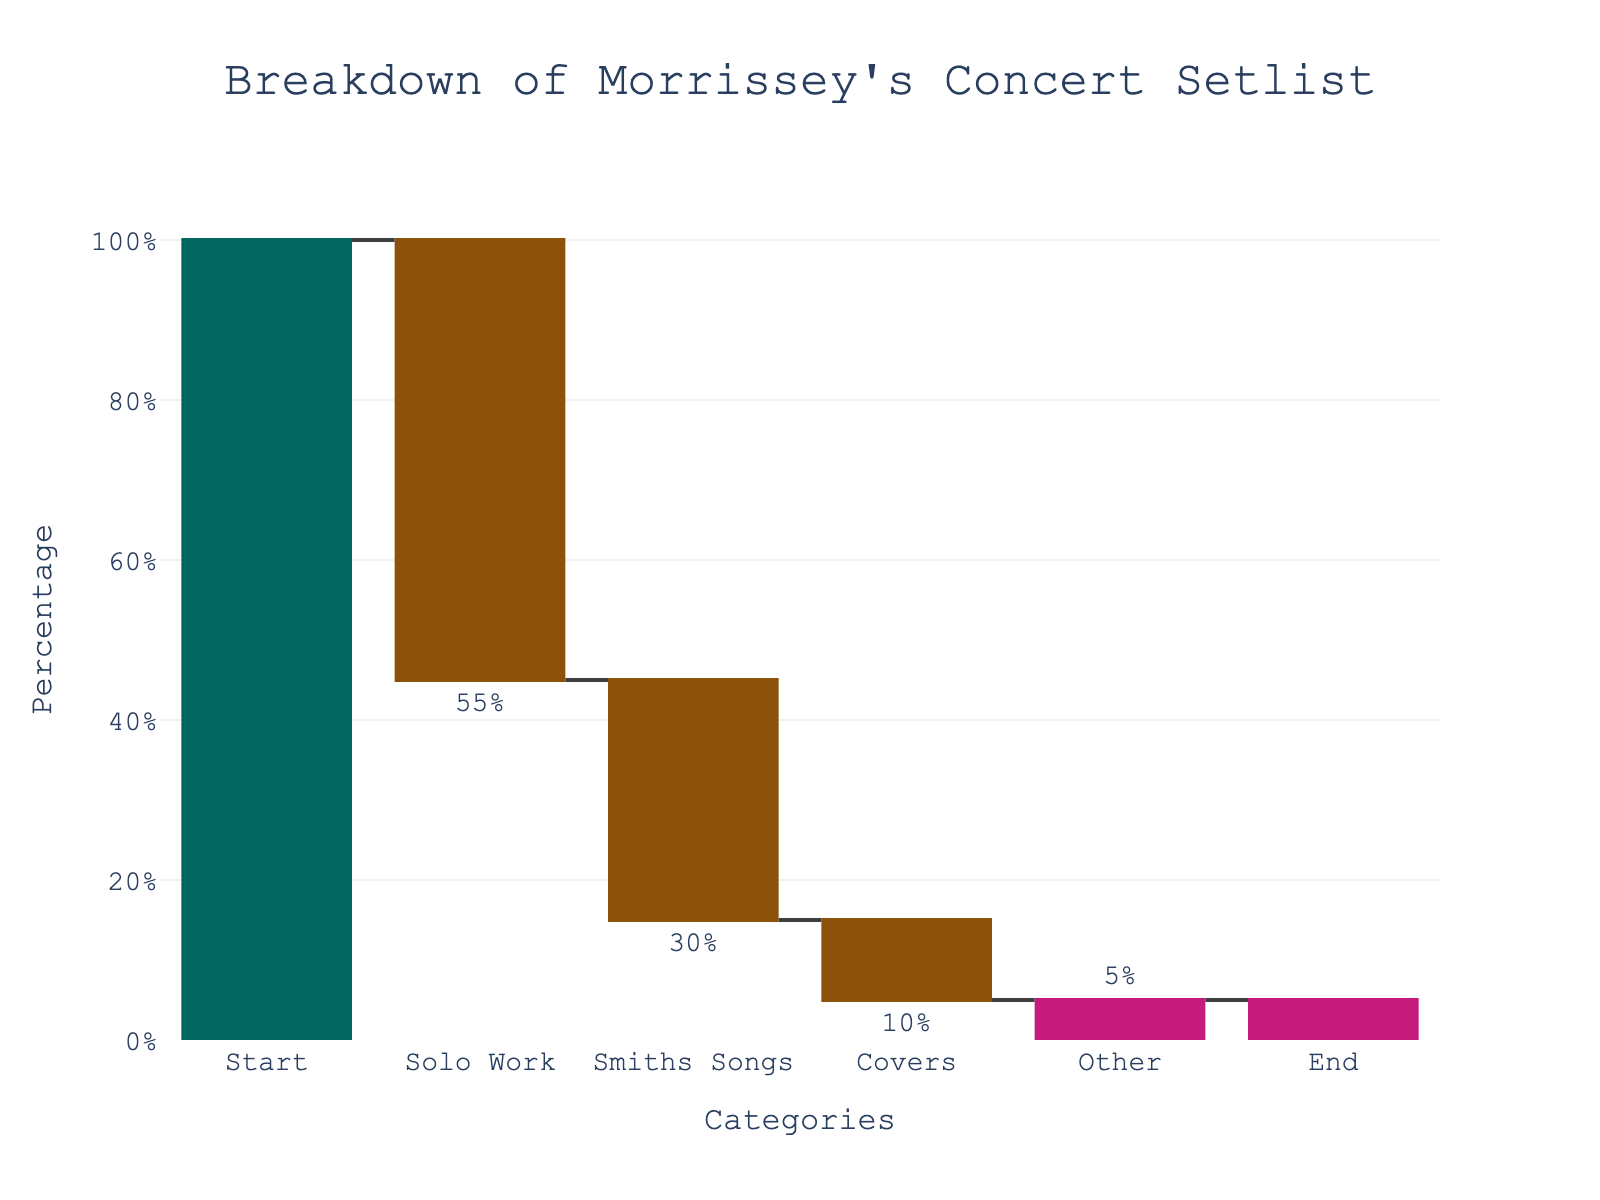What is the title of the chart? The title of the chart is displayed at the top of the figure. It reads "Breakdown of Morrissey's Concert Setlist."
Answer: Breakdown of Morrissey's Concert Setlist What are the categories listed on the x-axis? The categories on the x-axis are listed directly below the bars. They include Start, Solo Work, Smiths Songs, Covers, Other, and End.
Answer: Start, Solo Work, Smiths Songs, Covers, Other, End Which category has the highest percentage drop? By looking at the length of the bars, Solo Work has the highest percentage drop shown by the largest negative bar.
Answer: Solo Work What is the total percentage decrease for the Smiths Songs and Covers categories combined? The Smiths Songs category decreases by 30% and the Covers category decreases by 10%. To find the total percentage decrease, add the two values: 30% + 10% = 40%.
Answer: 40% How many categories decrease the setlist composition? The categories that decrease the setlist composition are identified by their negative value bars. There are four such categories: Solo Work, Smiths Songs, Covers, Other.
Answer: 4 What is the sum of the percentages for all categories excluding the Start and End categories? Excluding the Start and End categories, the percentages are -55% (Solo Work), -30% (Smiths Songs), -10% (Covers), and -5% (Other). Summing these gives: -55% + -30% + -10% + -5% = -100%.
Answer: -100% Which category contributes the least to the total percentage decrease? The category with the smallest negative bar represents the least contribution to the total percentage decrease. The Other category has a decrease of 5%, which is the smallest.
Answer: Other What is the percentage remaining after solo work and Smiths Songs categories are considered? Starting from 100%, subtract the percentages for Solo Work (-55%) and Smiths Songs (-30%). Calculation: 100% - 55% - 30% = 15%.
Answer: 15% How does the "Start" bar compare to the "End" bar? Both the Start and End bars are total bars. The Start bar is at 100% while the End bar is at 0%, showing a complete reduction.
Answer: The End bar is at 0% Does any category show an increase in the setlist composition? In a waterfall chart, an increase would be shown by an increasing bar. Here, there are no increasing bars; all categories decrease the composition.
Answer: No 